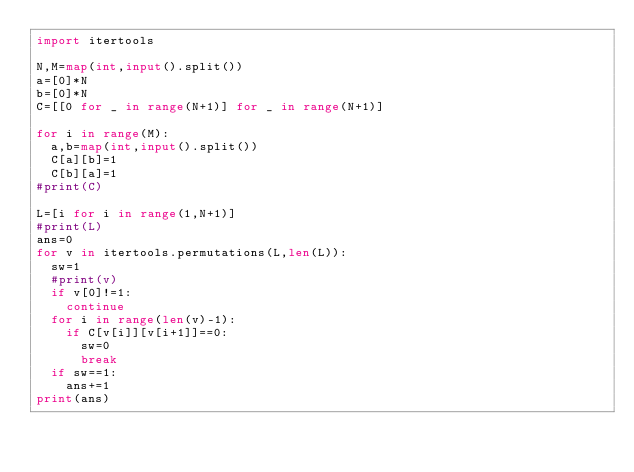Convert code to text. <code><loc_0><loc_0><loc_500><loc_500><_Python_>import itertools

N,M=map(int,input().split())
a=[0]*N
b=[0]*N
C=[[0 for _ in range(N+1)] for _ in range(N+1)]

for i in range(M):
  a,b=map(int,input().split())
  C[a][b]=1
  C[b][a]=1
#print(C)
  
L=[i for i in range(1,N+1)]
#print(L)
ans=0
for v in itertools.permutations(L,len(L)):
  sw=1
  #print(v)
  if v[0]!=1:
    continue
  for i in range(len(v)-1):
    if C[v[i]][v[i+1]]==0:
      sw=0
      break
  if sw==1:
    ans+=1
print(ans)</code> 